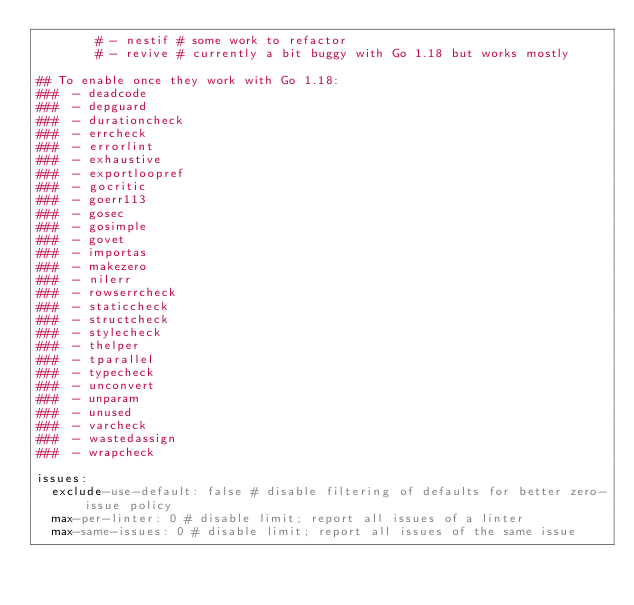<code> <loc_0><loc_0><loc_500><loc_500><_YAML_>        # - nestif # some work to refactor
        # - revive # currently a bit buggy with Go 1.18 but works mostly

## To enable once they work with Go 1.18:
###  - deadcode
###  - depguard
###  - durationcheck
###  - errcheck
###  - errorlint
###  - exhaustive
###  - exportloopref
###  - gocritic
###  - goerr113
###  - gosec
###  - gosimple
###  - govet
###  - importas
###  - makezero
###  - nilerr
###  - rowserrcheck
###  - staticcheck
###  - structcheck
###  - stylecheck
###  - thelper
###  - tparallel
###  - typecheck
###  - unconvert
###  - unparam
###  - unused
###  - varcheck
###  - wastedassign
###  - wrapcheck

issues:
  exclude-use-default: false # disable filtering of defaults for better zero-issue policy
  max-per-linter: 0 # disable limit; report all issues of a linter
  max-same-issues: 0 # disable limit; report all issues of the same issue
</code> 